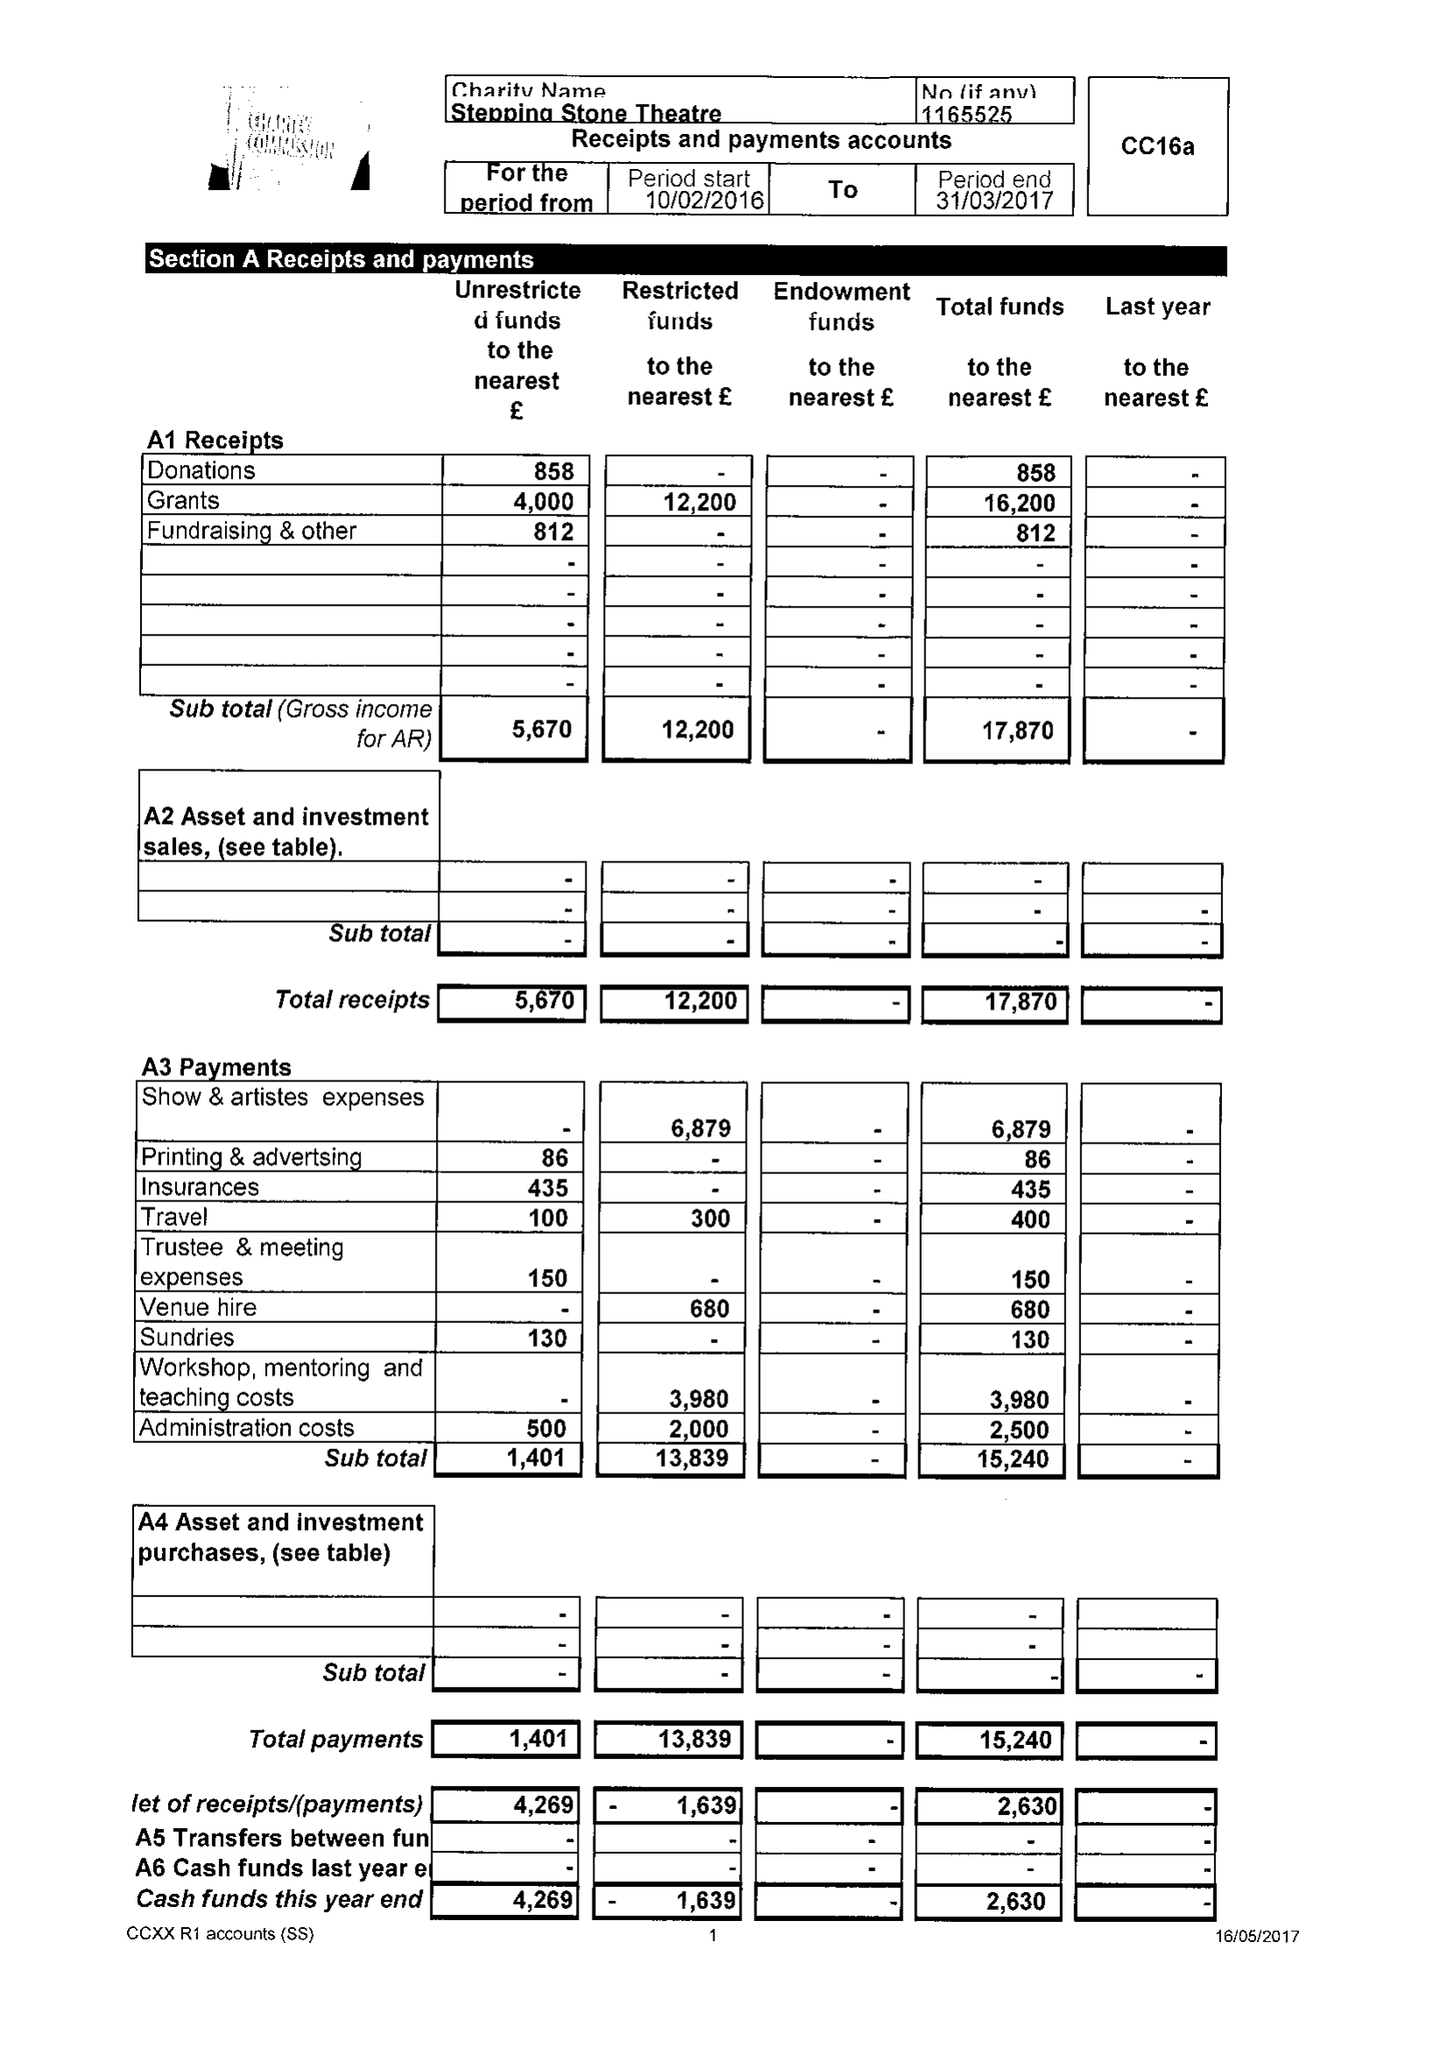What is the value for the address__post_town?
Answer the question using a single word or phrase. GAINSBOROUGH 